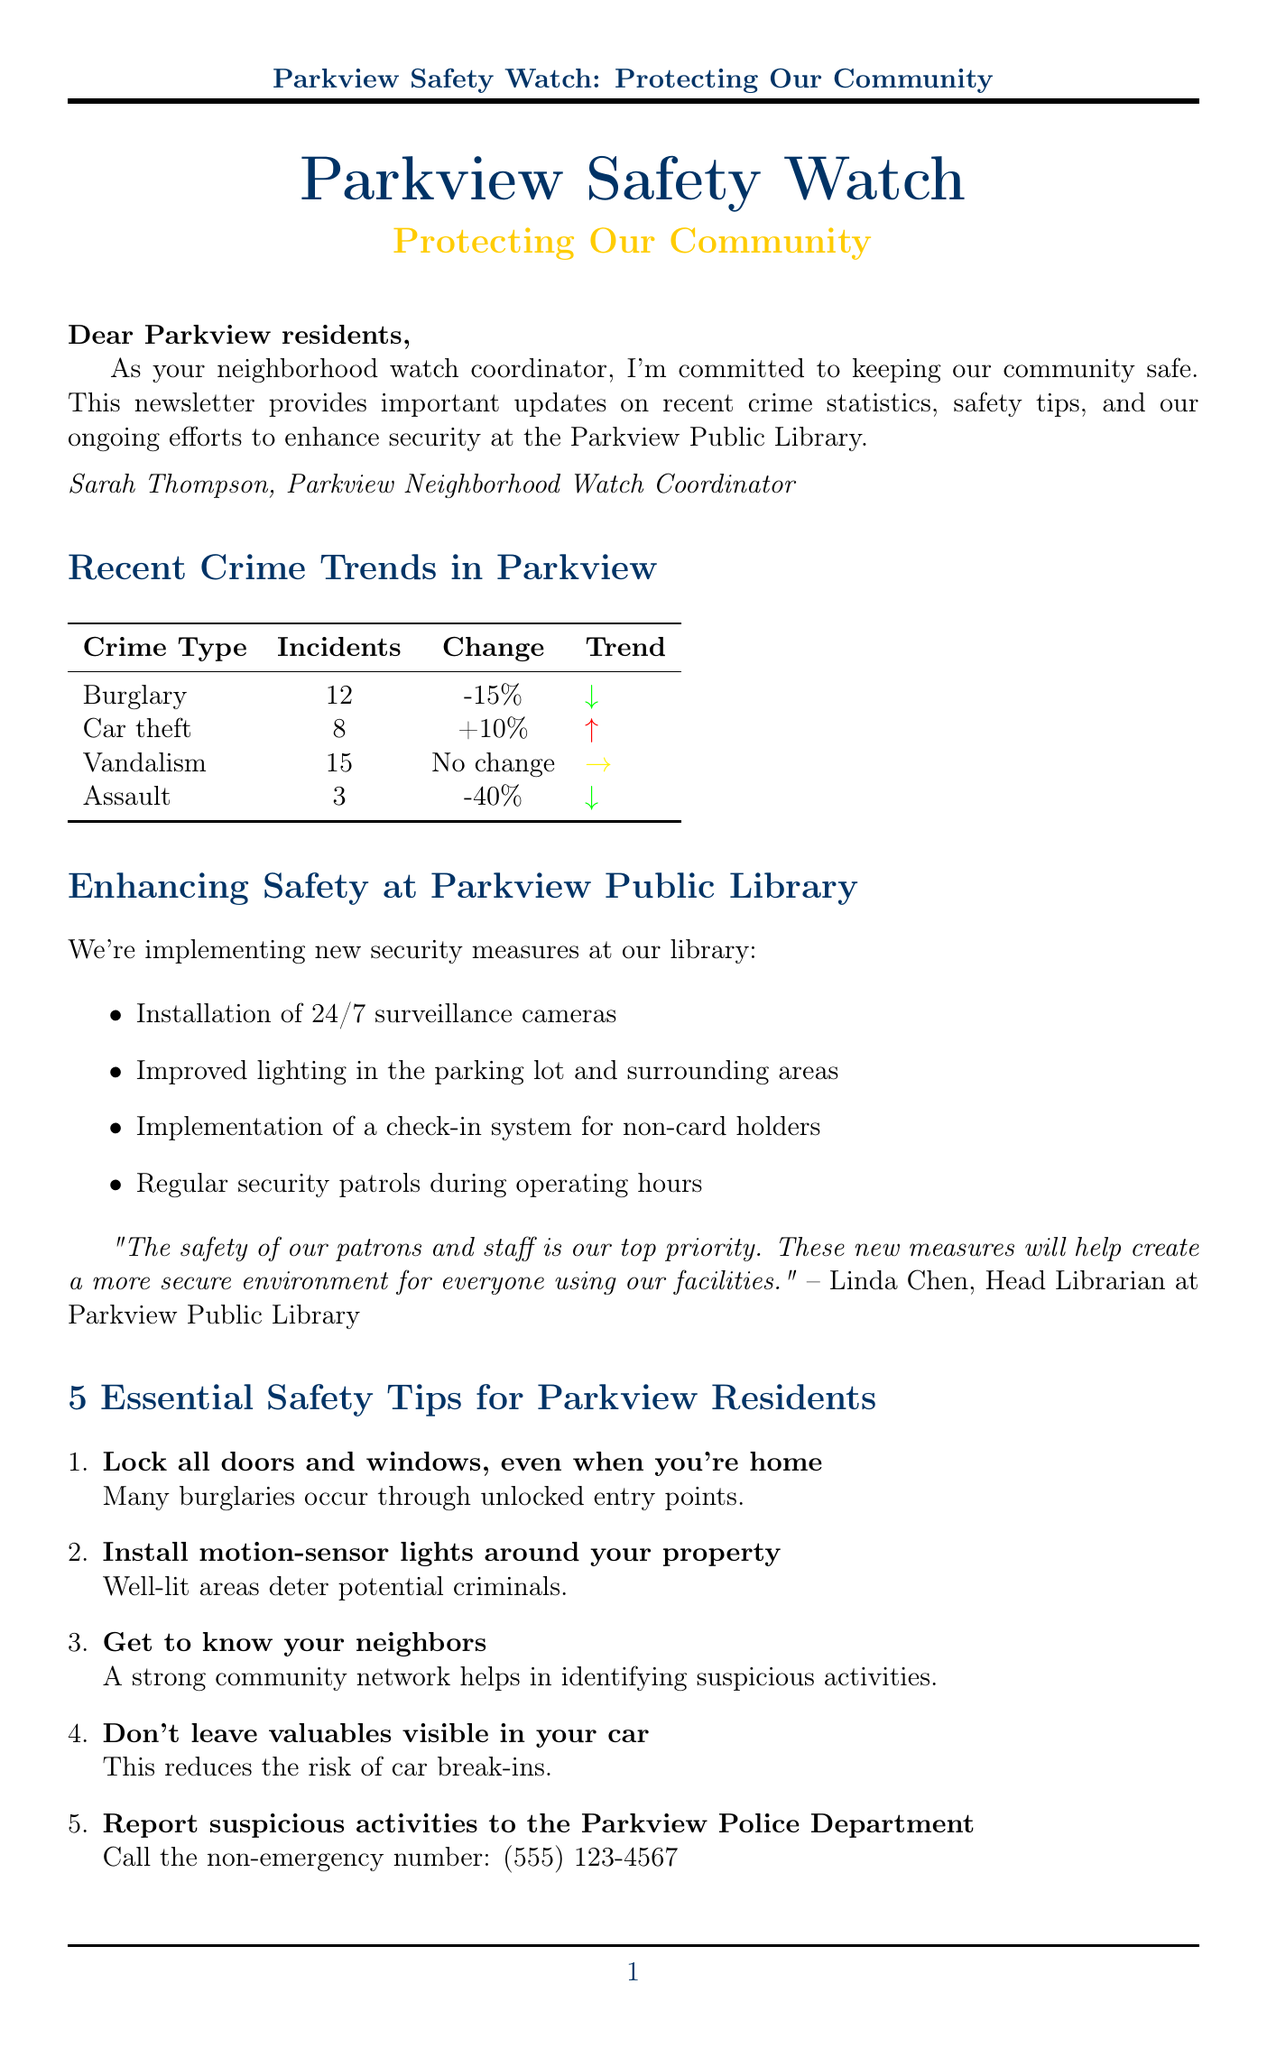What is the title of the newsletter? The title is stated at the beginning of the document.
Answer: Parkview Safety Watch: Protecting Our Community Who is the author of the newsletter? The author is mentioned in the introduction section of the document.
Answer: Sarah Thompson How many incidents of car theft were reported? The specific number of car theft incidents is provided in the crime statistics section.
Answer: 8 What percentage change in burglary incidents was reported? The change in burglary incidents compared to the last quarter is clearly stated.
Answer: -15% What is one of the security measures being implemented at the Parkview Public Library? Some measures are listed under the library security update section.
Answer: Installation of 24/7 surveillance cameras When is the upcoming safety awareness workshop scheduled? The date for the workshop is specified in the community event section.
Answer: Saturday, June 15th, 2023 Who is the guest speaker at the safety awareness workshop? The guest speaker is mentioned in the description of the workshop.
Answer: Officer Michael Rodriguez What is the non-emergency number for reporting suspicious activities? This number is provided in the safety tips section of the document.
Answer: (555) 123-4567 How many essential safety tips are provided for Parkview residents? The total number of tips is mentioned before they are listed.
Answer: 5 